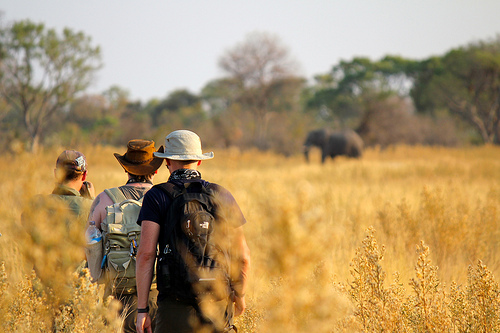Which color is the shirt? The shirt is black. 